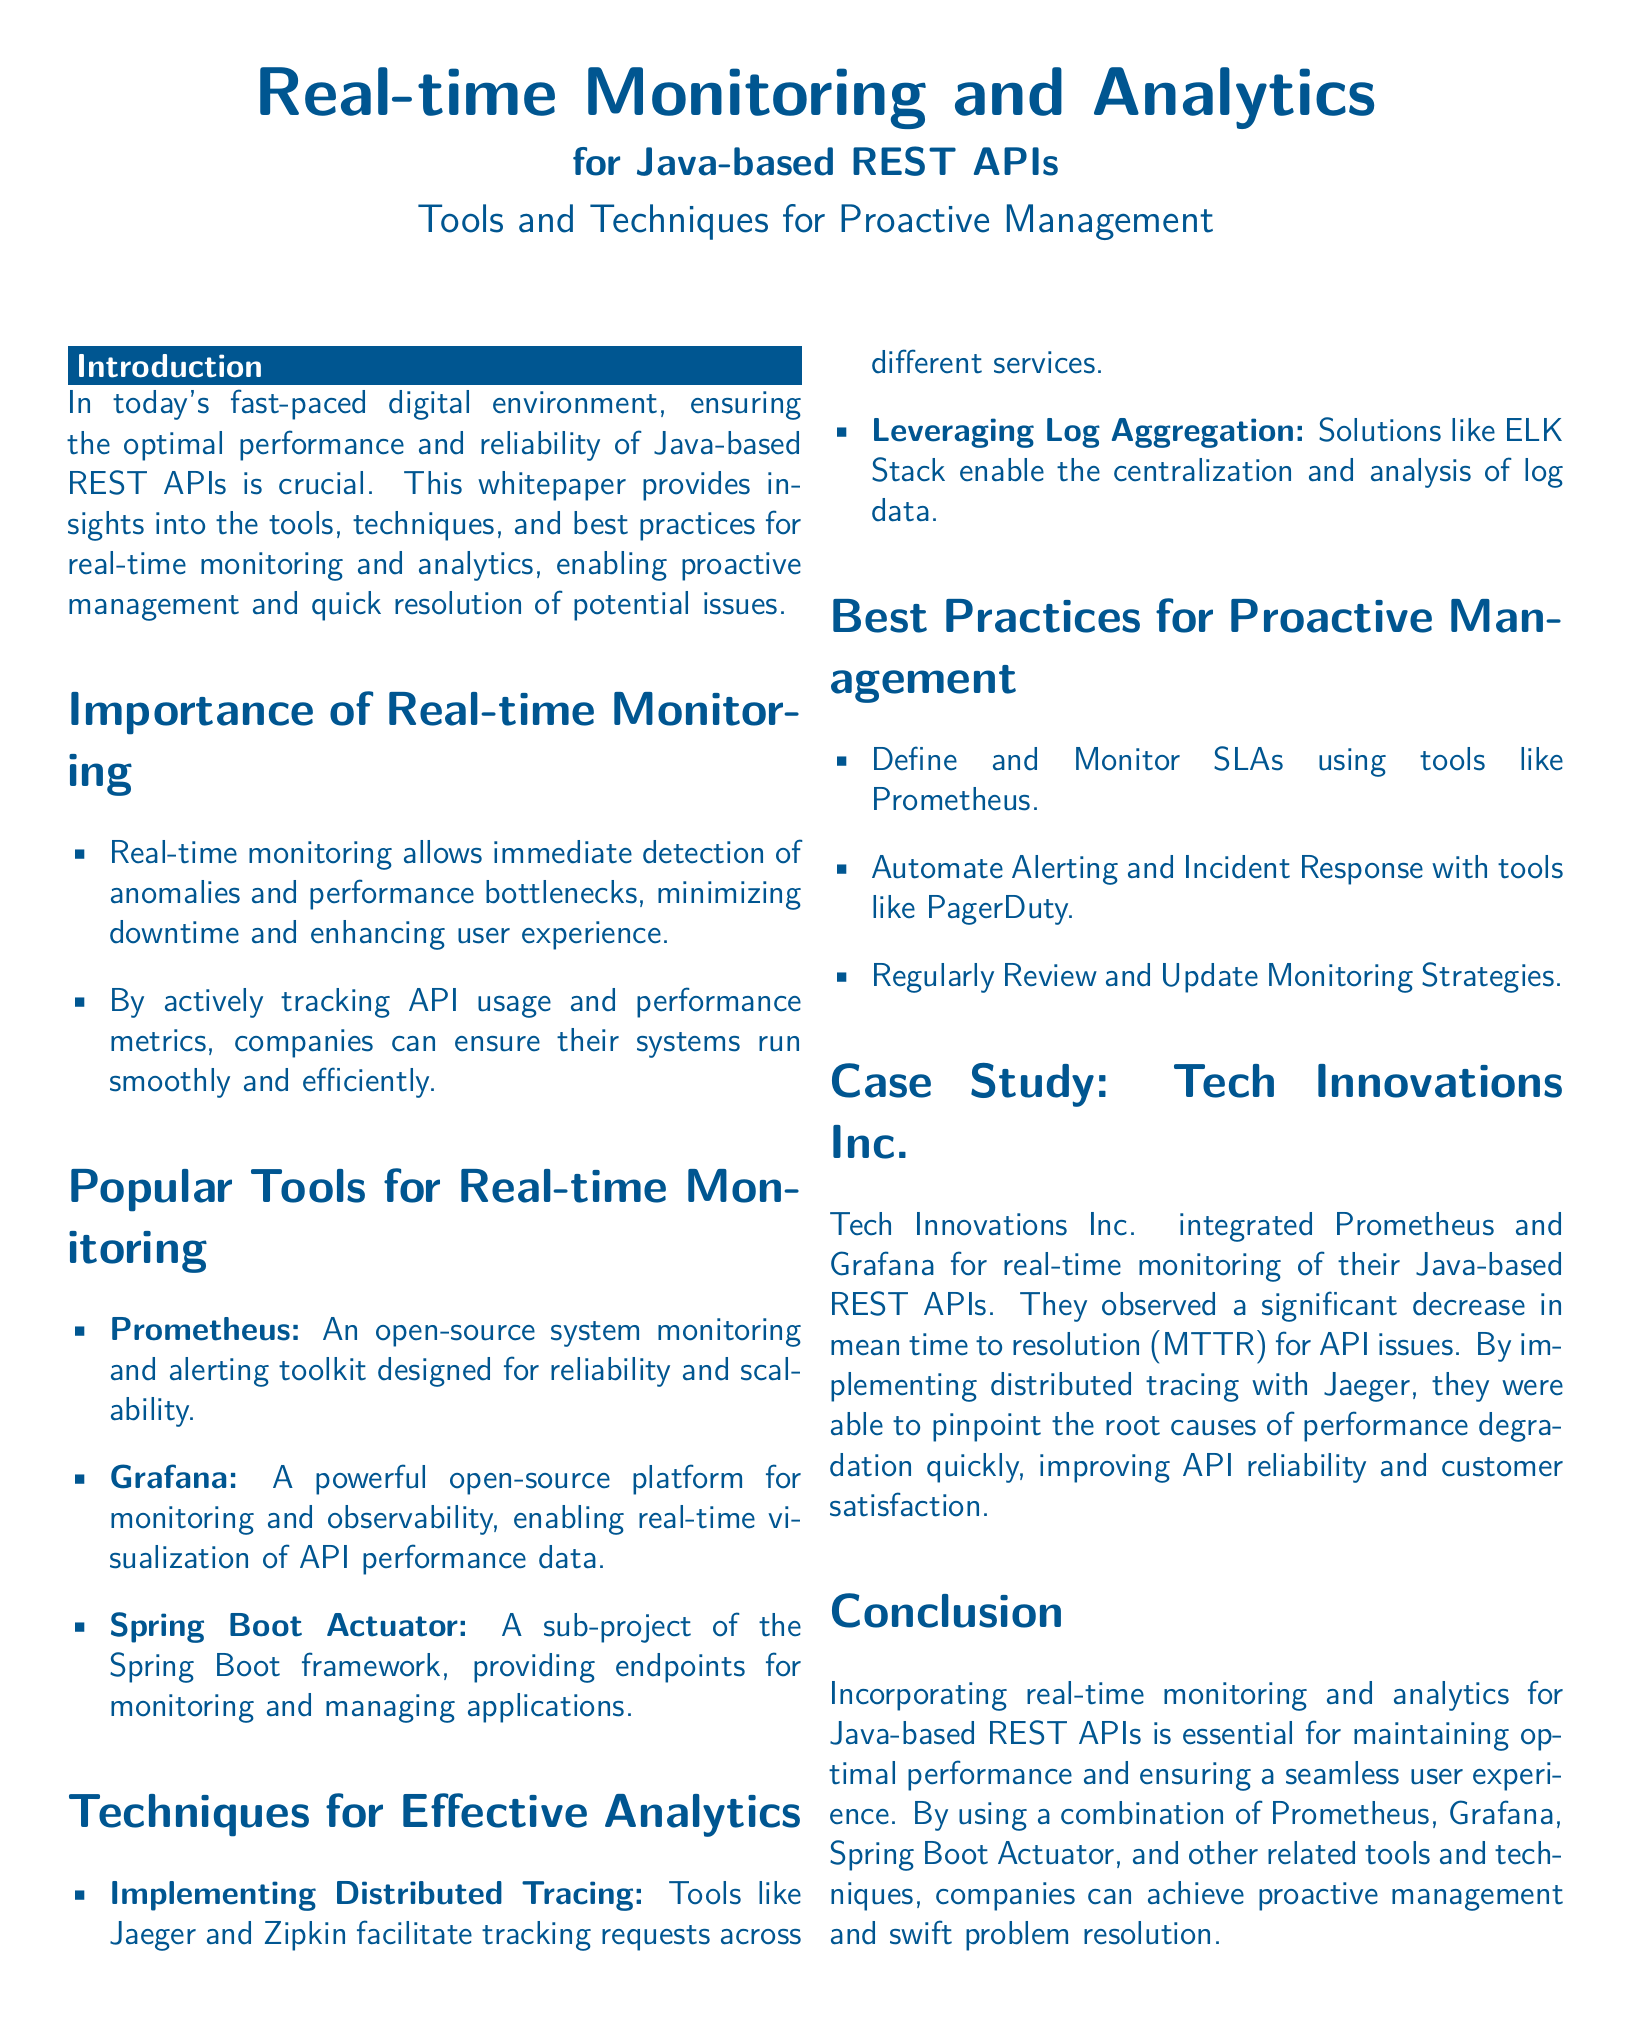What is the title of the document? The title is listed at the beginning of the document, emphasizing the main topic.
Answer: Real-time Monitoring and Analytics for Java-based REST APIs What are the two popular tools mentioned for real-time monitoring? The tools are explicitly mentioned in the section about popular tools for real-time monitoring.
Answer: Prometheus, Grafana Which project of the Spring Boot framework is referenced? The relevant project is specified in the section that discusses popular tools.
Answer: Spring Boot Actuator What technique is used for implementing distributed tracing? The techniques are mentioned alongside specific tools in the effective analytics section.
Answer: Jaeger, Zipkin What benefit did Tech Innovations Inc. observe after integration? The case study section highlights the positive outcome of implementing the tools.
Answer: Decrease in mean time to resolution (MTTR) What is one best practice for proactive management mentioned? Best practices are outlined in a dedicated section for proactive management.
Answer: Define and Monitor SLAs How does real-time monitoring affect user experience? The importance of real-time monitoring section specifies its significance for user experience.
Answer: Enhances user experience What is the last section title of the document? The conclusion summarizes the entire content and is the final part of the document.
Answer: Conclusion 